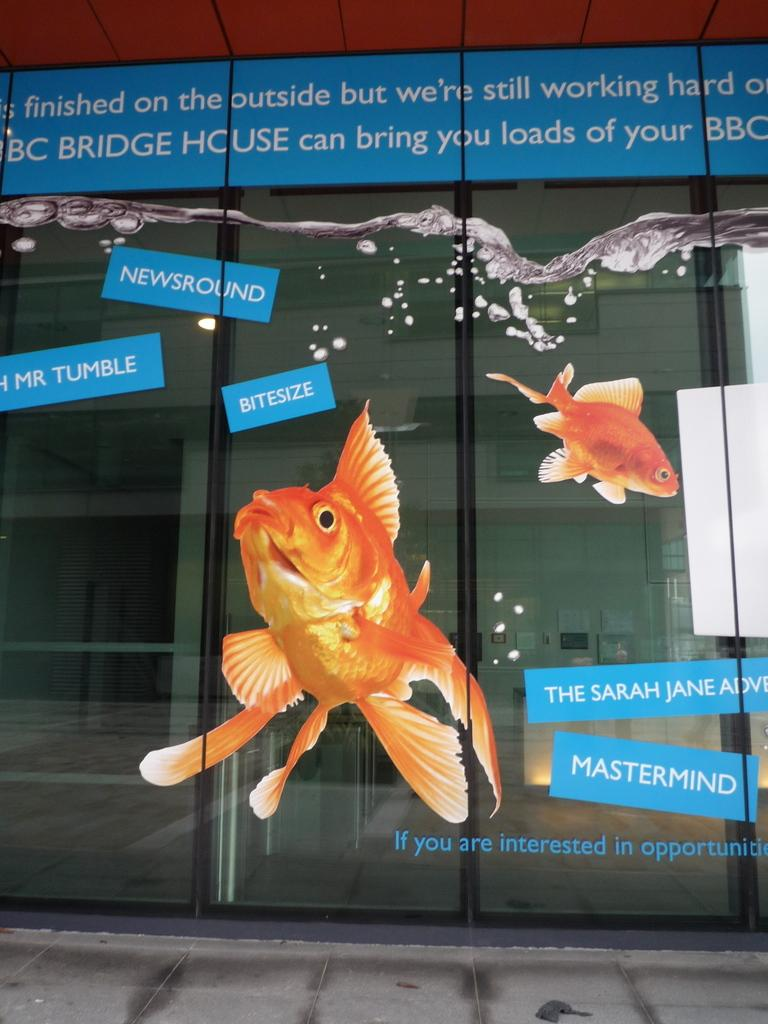What is located in the center of the image? There are posters in the center of the image. What is the surface on which the posters are placed? The posters are on a glass surface. What can be found on the posters? There is text written on the posters. Can you see any cracks in the glass surface in the image? There is no mention of any cracks in the glass surface in the provided facts, so we cannot determine if any cracks are present in the image. 